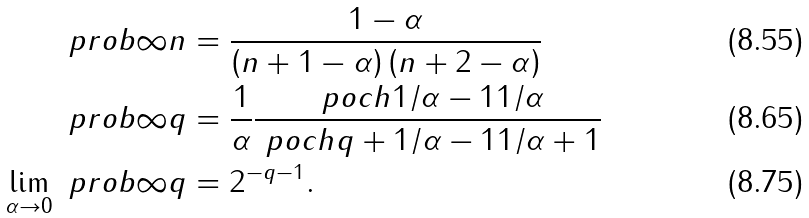<formula> <loc_0><loc_0><loc_500><loc_500>\ p r o b { \infty } { n } & = \frac { 1 - \alpha } { \left ( n + 1 - \alpha \right ) \left ( n + 2 - \alpha \right ) } \\ \ p r o b { \infty } { q } & = \frac { 1 } { \alpha } \frac { \ p o c h { 1 / \alpha - 1 } { 1 / \alpha } } { \ p o c h { q + 1 / \alpha - 1 } { 1 / \alpha + 1 } } \\ \lim _ { \alpha \to 0 } \ p r o b { \infty } { q } & = 2 ^ { - q - 1 } .</formula> 